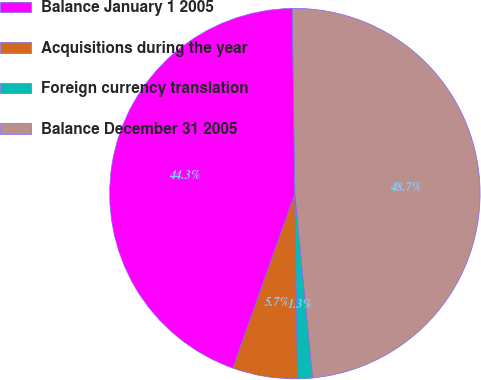Convert chart. <chart><loc_0><loc_0><loc_500><loc_500><pie_chart><fcel>Balance January 1 2005<fcel>Acquisitions during the year<fcel>Foreign currency translation<fcel>Balance December 31 2005<nl><fcel>44.34%<fcel>5.66%<fcel>1.3%<fcel>48.7%<nl></chart> 